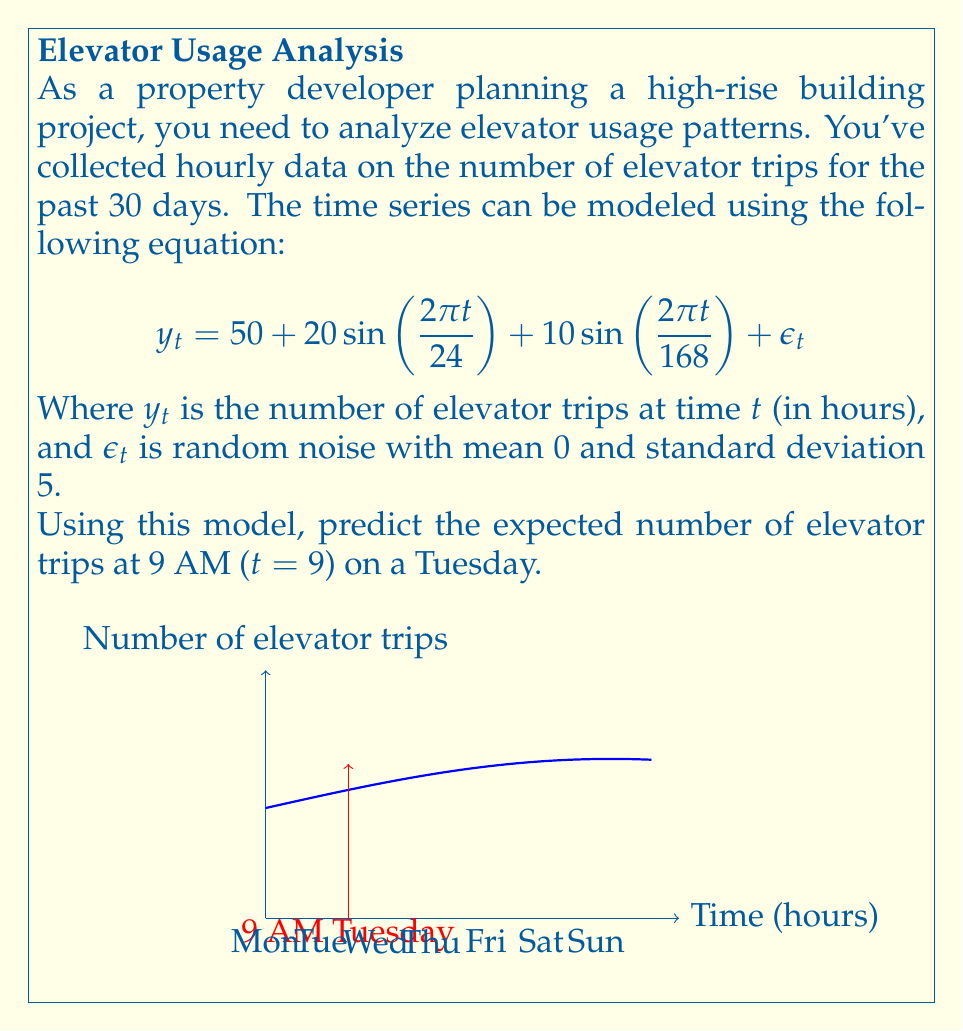Can you solve this math problem? To solve this problem, we need to use the given time series model and plug in the appropriate value for t. Let's break it down step-by-step:

1. The model is given as:
   $$ y_t = 50 + 20 \sin(\frac{2\pi t}{24}) + 10 \sin(\frac{2\pi t}{168}) + \epsilon_t $$

2. We need to predict for 9 AM on a Tuesday. Since the time series starts at the beginning of Monday (t = 0), 9 AM on Tuesday would be t = 33 hours from the start.

3. Plug in t = 33 into the equation:
   $$ y_{33} = 50 + 20 \sin(\frac{2\pi \cdot 33}{24}) + 10 \sin(\frac{2\pi \cdot 33}{168}) + \epsilon_{33} $$

4. Simplify the arguments inside the sine functions:
   $$ y_{33} = 50 + 20 \sin(\frac{11\pi}{4}) + 10 \sin(\frac{11\pi}{28}) + \epsilon_{33} $$

5. Calculate the sine values:
   $\sin(\frac{11\pi}{4}) \approx 0.7071$
   $\sin(\frac{11\pi}{28}) \approx 0.8910$

6. Plug these values back into the equation:
   $$ y_{33} = 50 + 20 \cdot 0.7071 + 10 \cdot 0.8910 + \epsilon_{33} $$
   $$ y_{33} = 50 + 14.142 + 8.910 + \epsilon_{33} $$
   $$ y_{33} = 73.052 + \epsilon_{33} $$

7. Since $\epsilon_{33}$ is random noise with mean 0, for the expected value, we can ignore it.

Therefore, the expected number of elevator trips at 9 AM on a Tuesday is approximately 73.052.
Answer: 73.052 trips 